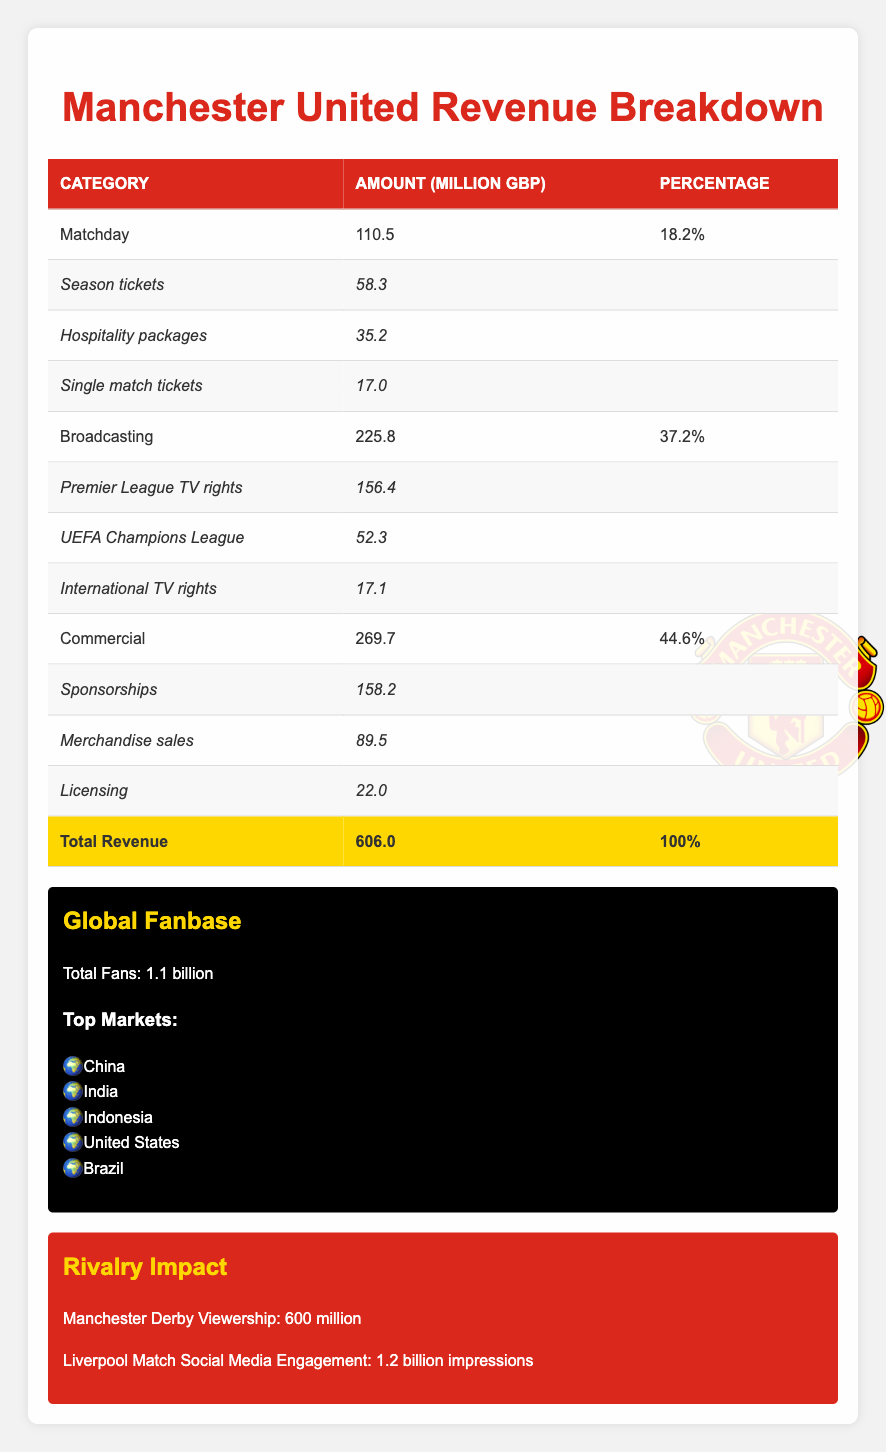What is the total revenue for Manchester United in the fiscal year 2021/2022? The total revenue is listed in the table under the "Total Revenue" row, which shows an amount of 606.0 million GBP.
Answer: 606.0 million GBP What category contributed the most to Manchester United's revenue? Looking at the "Amount" column, the "Commercial" category has the highest value of 269.7 million GBP compared to "Matchday" and "Broadcasting."
Answer: Commercial What percentage of the total revenue came from broadcasting? The percentage for the "Broadcasting" category is provided in the table as 37.2%. This value can be directly retrieved from the table.
Answer: 37.2% How much revenue was generated from season tickets? The table specifies that the revenue generated from "Season tickets" is 58.3 million GBP, listed under the "Matchday" category.
Answer: 58.3 million GBP Which revenue category had the lowest contribution in terms of percentage? By examining the percentage values next to each category, "Matchday" has the lowest contribution at 18.2%. Therefore, it is the category with the least percentage contribution to total revenue.
Answer: Matchday What is the combined revenue from merchandise sales and licensing? To find the combined revenue, we need to sum the "Merchandise sales" (89.5 million GBP) and "Licensing" (22.0 million GBP). This results in 89.5 + 22.0 = 111.5 million GBP.
Answer: 111.5 million GBP Is the total revenue from "Matchday" greater than that from "Broadcasting"? From the table, "Matchday" revenue is 110.5 million GBP while "Broadcasting" revenue is 225.8 million GBP. Since 110.5 < 225.8, the statement is false.
Answer: No Calculate the total revenue share of "Commercial" and "Broadcasting" categories combined. The amounts for "Commercial" (269.7 million GBP) and "Broadcasting" (225.8 million GBP) need to be added together: 269.7 + 225.8 = 495.5 million GBP. To find the share, divide this by the total revenue (606.0 million GBP) and multiply by 100, giving (495.5 / 606.0) * 100 ≈ 81.8%.
Answer: 81.8% What is the total amount raised by single match tickets compared to hospitality packages? "Single match tickets" revenue is 17.0 million GBP while "Hospitality packages" revenue is 35.2 million GBP. When combining both, we find 17.0 + 35.2 = 52.2 million GBP.
Answer: 52.2 million GBP 